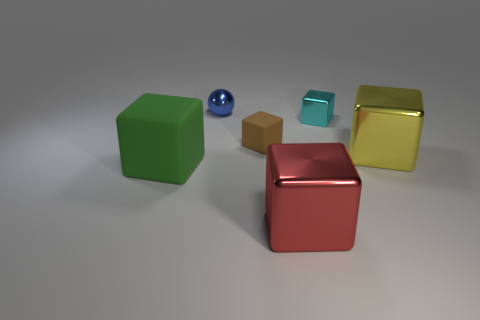Subtract all brown blocks. How many blocks are left? 4 Subtract all gray spheres. Subtract all blue blocks. How many spheres are left? 1 Add 4 tiny cyan blocks. How many objects exist? 10 Subtract all balls. How many objects are left? 5 Add 6 blue metallic objects. How many blue metallic objects are left? 7 Add 2 big yellow things. How many big yellow things exist? 3 Subtract 1 brown cubes. How many objects are left? 5 Subtract all gray rubber cylinders. Subtract all small blue objects. How many objects are left? 5 